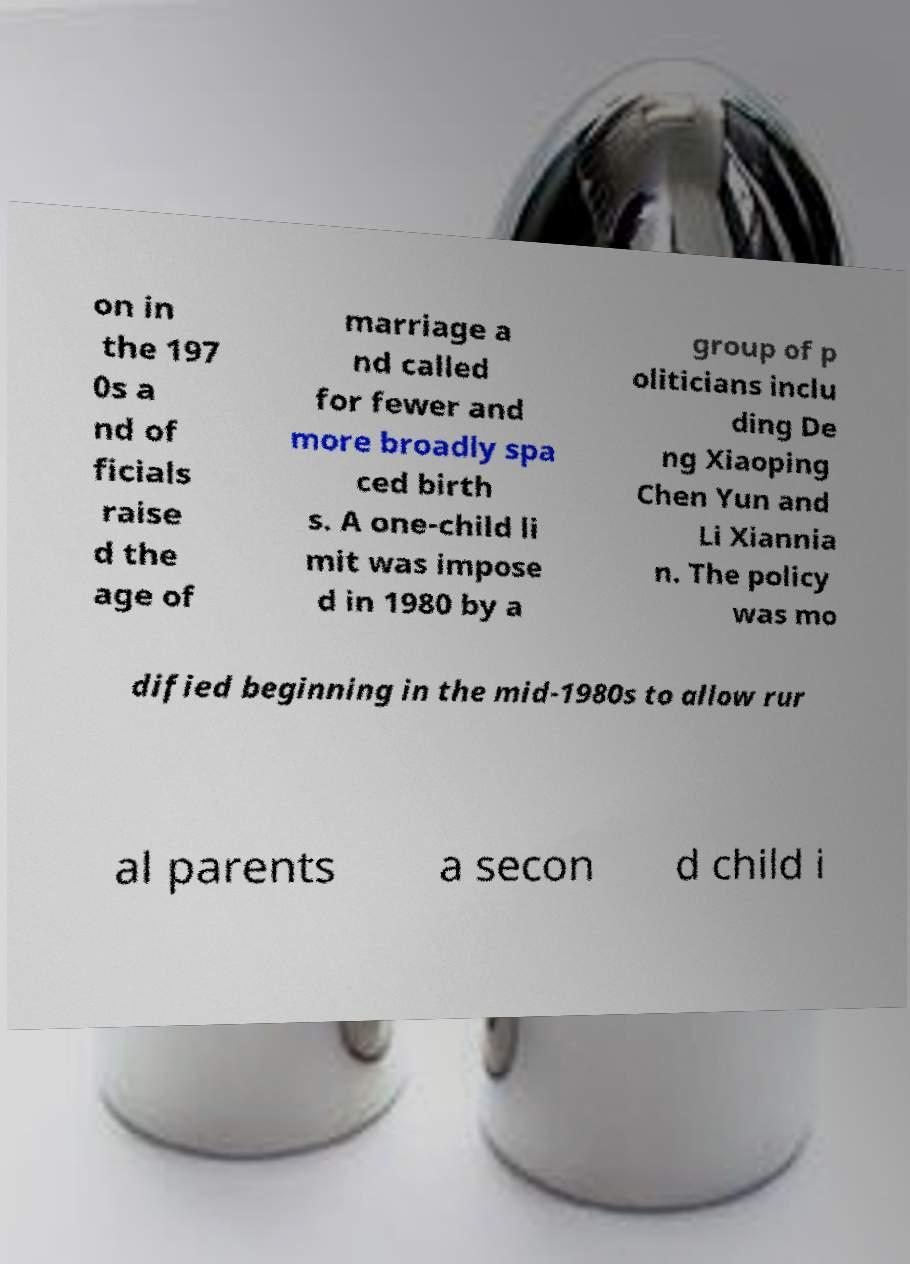Could you extract and type out the text from this image? on in the 197 0s a nd of ficials raise d the age of marriage a nd called for fewer and more broadly spa ced birth s. A one-child li mit was impose d in 1980 by a group of p oliticians inclu ding De ng Xiaoping Chen Yun and Li Xiannia n. The policy was mo dified beginning in the mid-1980s to allow rur al parents a secon d child i 